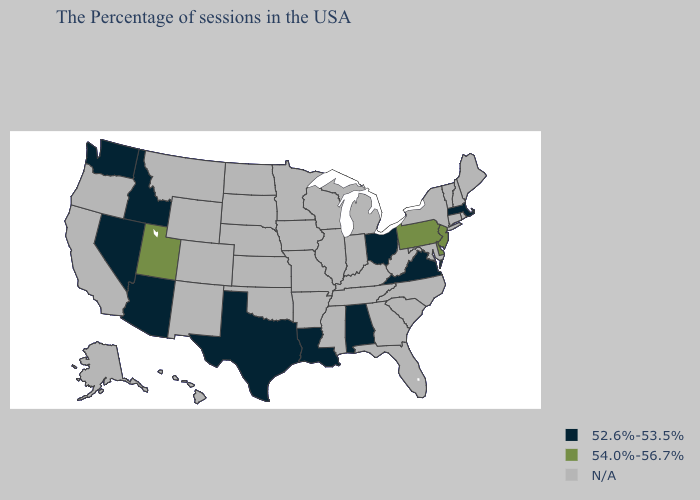What is the value of Minnesota?
Concise answer only. N/A. Which states have the lowest value in the USA?
Concise answer only. Massachusetts, Virginia, Ohio, Alabama, Louisiana, Texas, Arizona, Idaho, Nevada, Washington. Name the states that have a value in the range N/A?
Give a very brief answer. Maine, Rhode Island, New Hampshire, Vermont, Connecticut, New York, Maryland, North Carolina, South Carolina, West Virginia, Florida, Georgia, Michigan, Kentucky, Indiana, Tennessee, Wisconsin, Illinois, Mississippi, Missouri, Arkansas, Minnesota, Iowa, Kansas, Nebraska, Oklahoma, South Dakota, North Dakota, Wyoming, Colorado, New Mexico, Montana, California, Oregon, Alaska, Hawaii. What is the value of Rhode Island?
Answer briefly. N/A. What is the lowest value in the South?
Concise answer only. 52.6%-53.5%. How many symbols are there in the legend?
Short answer required. 3. Name the states that have a value in the range 54.0%-56.7%?
Quick response, please. New Jersey, Delaware, Pennsylvania, Utah. Name the states that have a value in the range N/A?
Concise answer only. Maine, Rhode Island, New Hampshire, Vermont, Connecticut, New York, Maryland, North Carolina, South Carolina, West Virginia, Florida, Georgia, Michigan, Kentucky, Indiana, Tennessee, Wisconsin, Illinois, Mississippi, Missouri, Arkansas, Minnesota, Iowa, Kansas, Nebraska, Oklahoma, South Dakota, North Dakota, Wyoming, Colorado, New Mexico, Montana, California, Oregon, Alaska, Hawaii. Does the first symbol in the legend represent the smallest category?
Quick response, please. Yes. How many symbols are there in the legend?
Write a very short answer. 3. What is the value of Wyoming?
Short answer required. N/A. Name the states that have a value in the range 54.0%-56.7%?
Write a very short answer. New Jersey, Delaware, Pennsylvania, Utah. Which states have the highest value in the USA?
Short answer required. New Jersey, Delaware, Pennsylvania, Utah. 